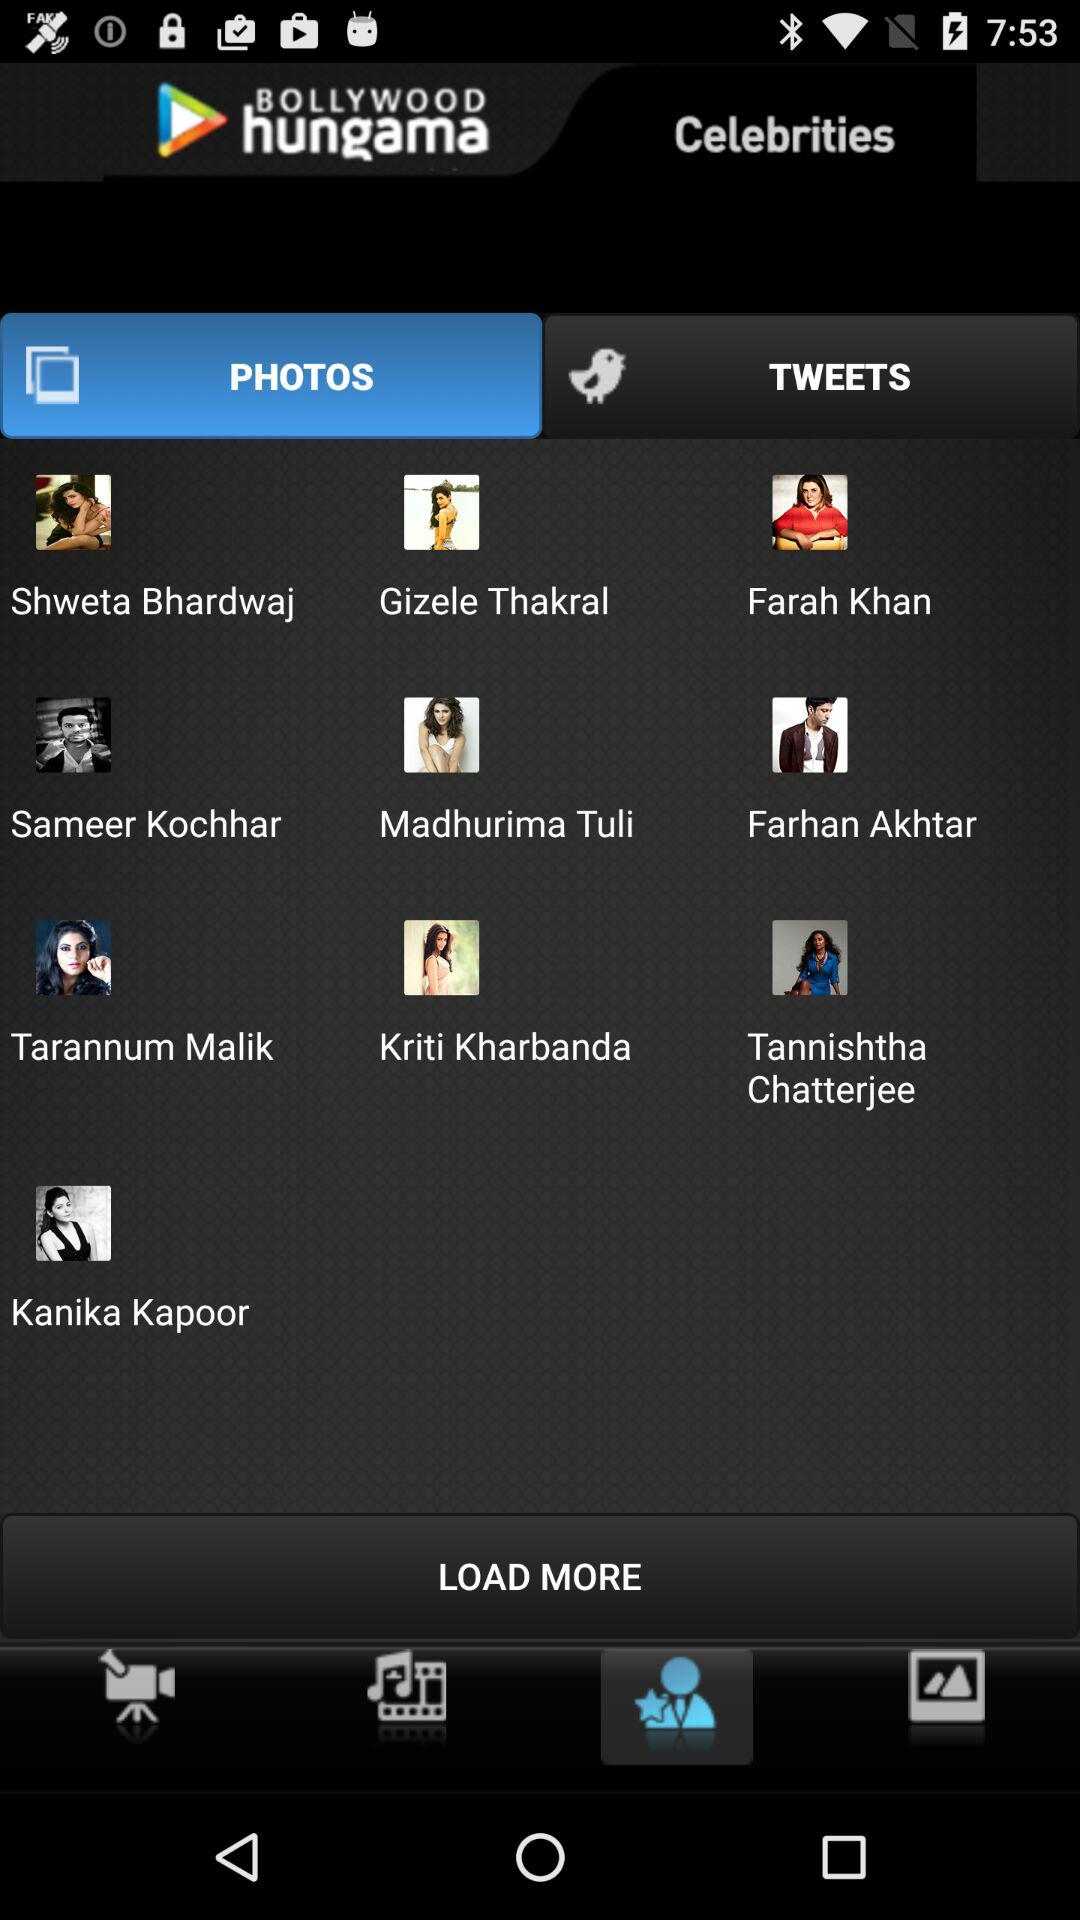What is the application name? The application name is "BOLLYWOOD hungama". 